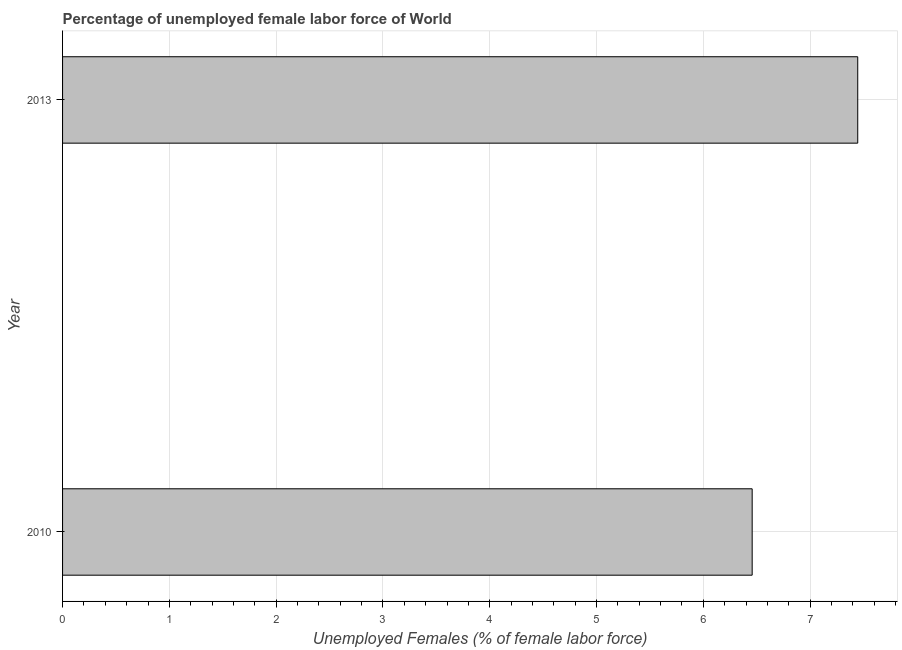What is the title of the graph?
Your answer should be very brief. Percentage of unemployed female labor force of World. What is the label or title of the X-axis?
Make the answer very short. Unemployed Females (% of female labor force). What is the label or title of the Y-axis?
Provide a succinct answer. Year. What is the total unemployed female labour force in 2010?
Provide a succinct answer. 6.46. Across all years, what is the maximum total unemployed female labour force?
Your answer should be very brief. 7.45. Across all years, what is the minimum total unemployed female labour force?
Offer a terse response. 6.46. In which year was the total unemployed female labour force minimum?
Provide a succinct answer. 2010. What is the sum of the total unemployed female labour force?
Offer a terse response. 13.9. What is the difference between the total unemployed female labour force in 2010 and 2013?
Provide a succinct answer. -0.99. What is the average total unemployed female labour force per year?
Your answer should be compact. 6.95. What is the median total unemployed female labour force?
Offer a very short reply. 6.95. Do a majority of the years between 2010 and 2013 (inclusive) have total unemployed female labour force greater than 4.2 %?
Offer a terse response. Yes. What is the ratio of the total unemployed female labour force in 2010 to that in 2013?
Keep it short and to the point. 0.87. Is the total unemployed female labour force in 2010 less than that in 2013?
Your answer should be compact. Yes. In how many years, is the total unemployed female labour force greater than the average total unemployed female labour force taken over all years?
Keep it short and to the point. 1. How many bars are there?
Provide a succinct answer. 2. Are all the bars in the graph horizontal?
Provide a succinct answer. Yes. Are the values on the major ticks of X-axis written in scientific E-notation?
Make the answer very short. No. What is the Unemployed Females (% of female labor force) of 2010?
Offer a terse response. 6.46. What is the Unemployed Females (% of female labor force) of 2013?
Provide a short and direct response. 7.45. What is the difference between the Unemployed Females (% of female labor force) in 2010 and 2013?
Offer a very short reply. -0.99. What is the ratio of the Unemployed Females (% of female labor force) in 2010 to that in 2013?
Your answer should be compact. 0.87. 